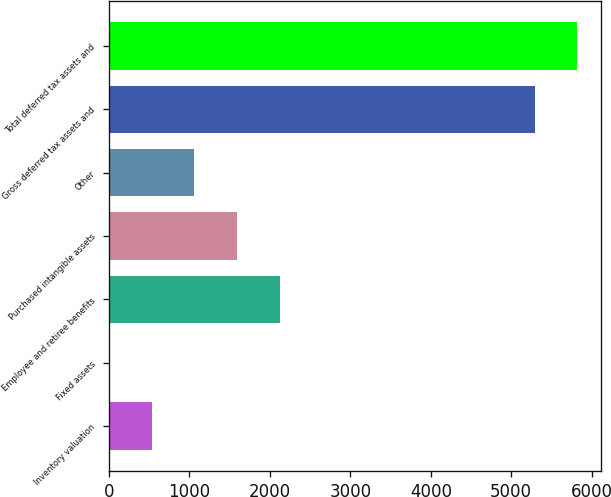Convert chart. <chart><loc_0><loc_0><loc_500><loc_500><bar_chart><fcel>Inventory valuation<fcel>Fixed assets<fcel>Employee and retiree benefits<fcel>Purchased intangible assets<fcel>Other<fcel>Gross deferred tax assets and<fcel>Total deferred tax assets and<nl><fcel>533.6<fcel>5<fcel>2119.4<fcel>1590.8<fcel>1062.2<fcel>5291<fcel>5819.6<nl></chart> 